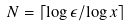Convert formula to latex. <formula><loc_0><loc_0><loc_500><loc_500>N = \lceil \log \epsilon / \log x \rceil</formula> 